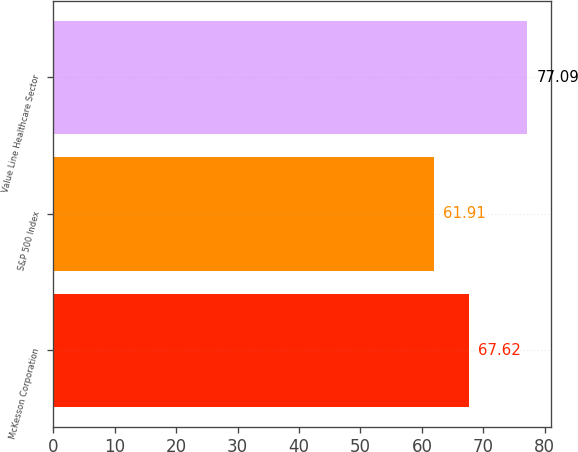Convert chart to OTSL. <chart><loc_0><loc_0><loc_500><loc_500><bar_chart><fcel>McKesson Corporation<fcel>S&P 500 Index<fcel>Value Line Healthcare Sector<nl><fcel>67.62<fcel>61.91<fcel>77.09<nl></chart> 